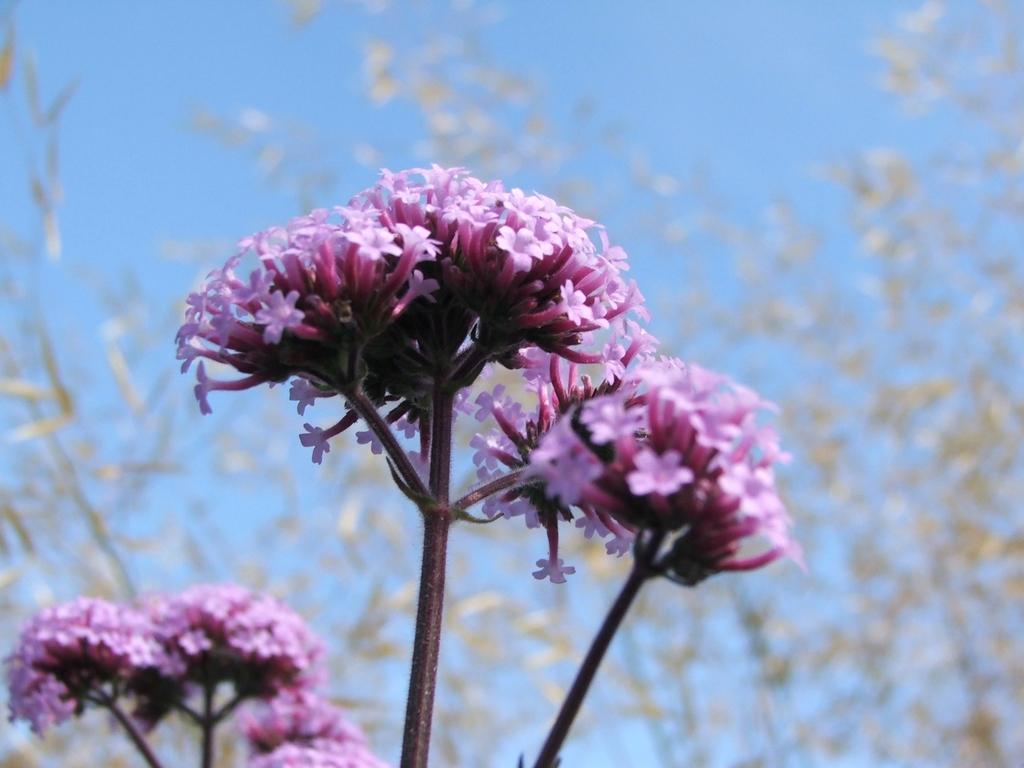What is the main subject of the image? The main subject of the image is bunches of flowers with stems. Can you describe the background of the image? The background of the image is blurred. Where are some flowers and stems located in the image? Flowers and stems are visible in the bottom left corner of the image. What type of hobbies do the flowers in the image enjoy? Flowers do not have hobbies, as they are inanimate objects. 